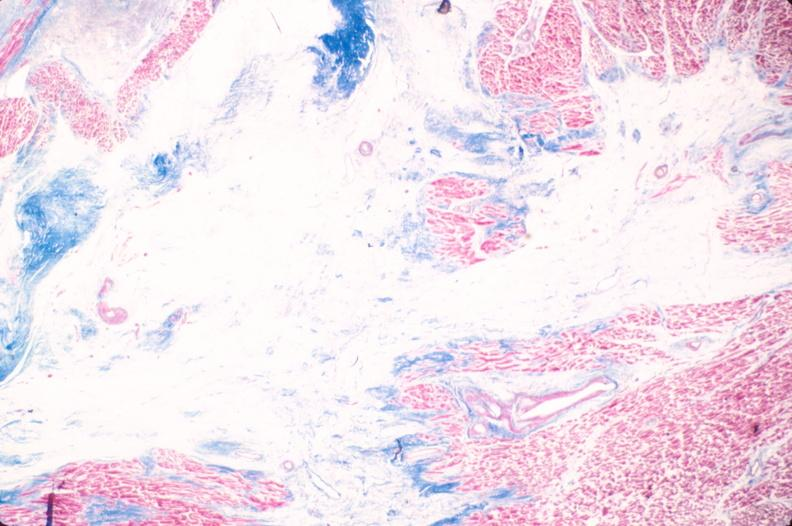does fat necrosis show heart, old myocardial infarction with fibrosis, trichrome?
Answer the question using a single word or phrase. No 